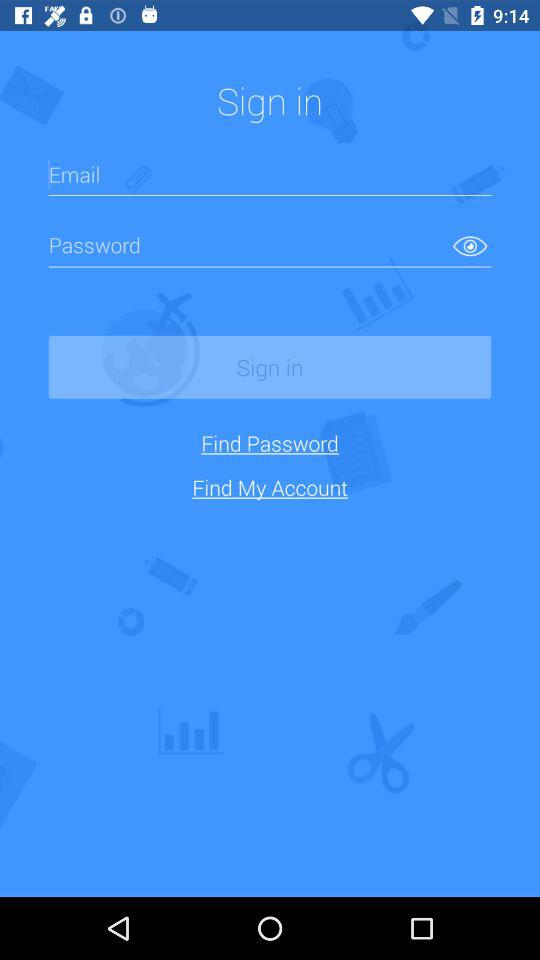Can we reset password?
When the provided information is insufficient, respond with <no answer>. <no answer> 